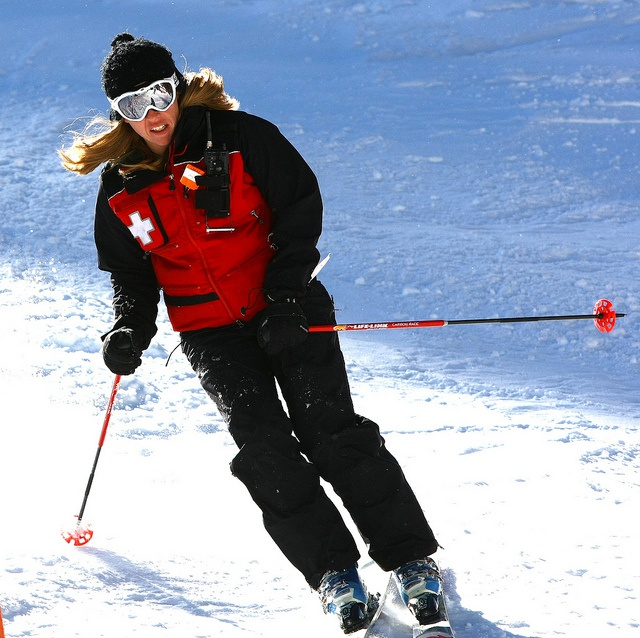Describe the objects in this image and their specific colors. I can see people in gray, black, maroon, and white tones and skis in gray, white, black, and darkgray tones in this image. 